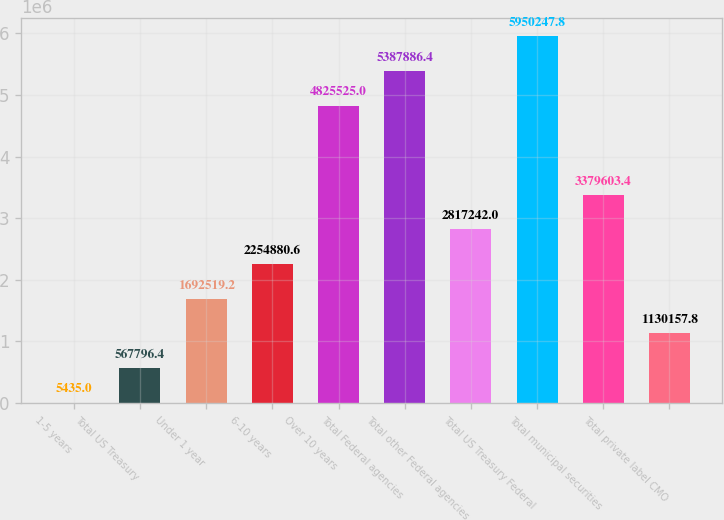Convert chart. <chart><loc_0><loc_0><loc_500><loc_500><bar_chart><fcel>1-5 years<fcel>Total US Treasury<fcel>Under 1 year<fcel>6-10 years<fcel>Over 10 years<fcel>Total Federal agencies<fcel>Total other Federal agencies<fcel>Total US Treasury Federal<fcel>Total municipal securities<fcel>Total private label CMO<nl><fcel>5435<fcel>567796<fcel>1.69252e+06<fcel>2.25488e+06<fcel>4.82552e+06<fcel>5.38789e+06<fcel>2.81724e+06<fcel>5.95025e+06<fcel>3.3796e+06<fcel>1.13016e+06<nl></chart> 